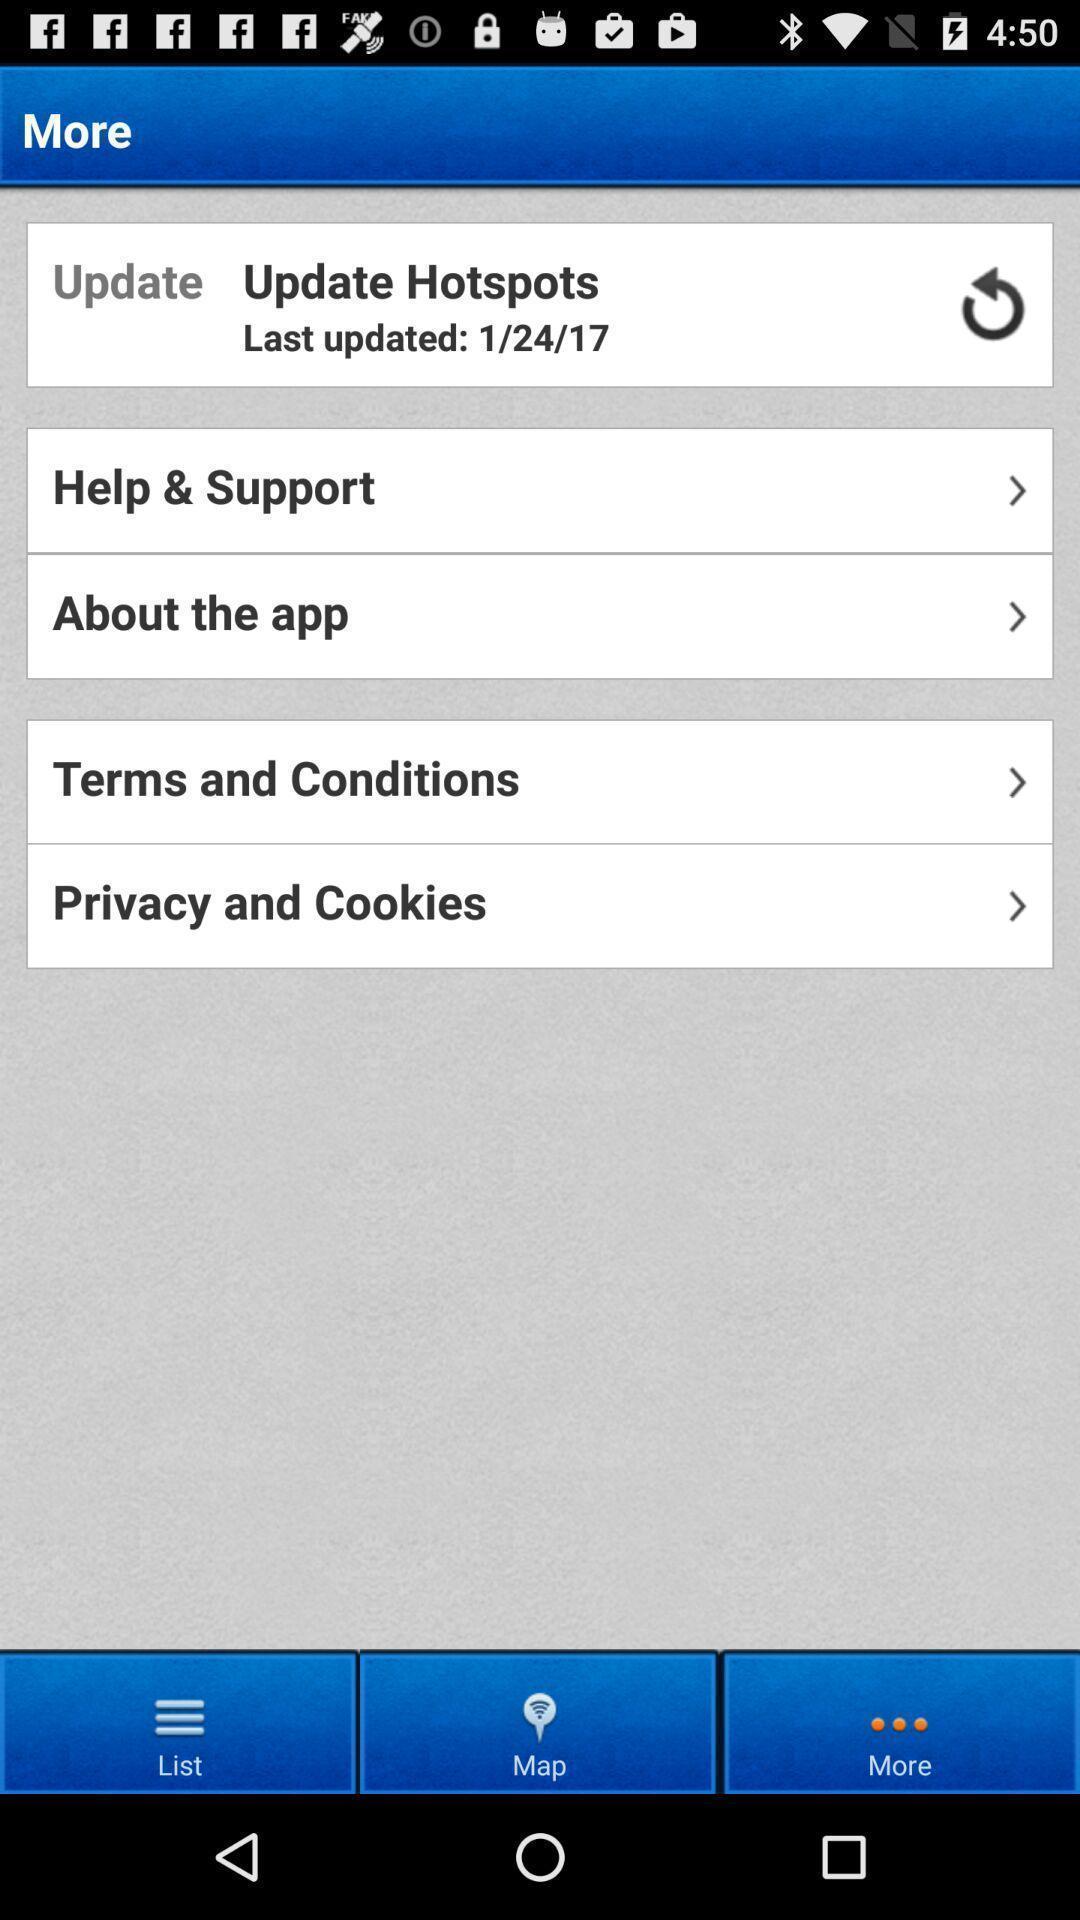Provide a detailed account of this screenshot. Page showing options related to an app. 